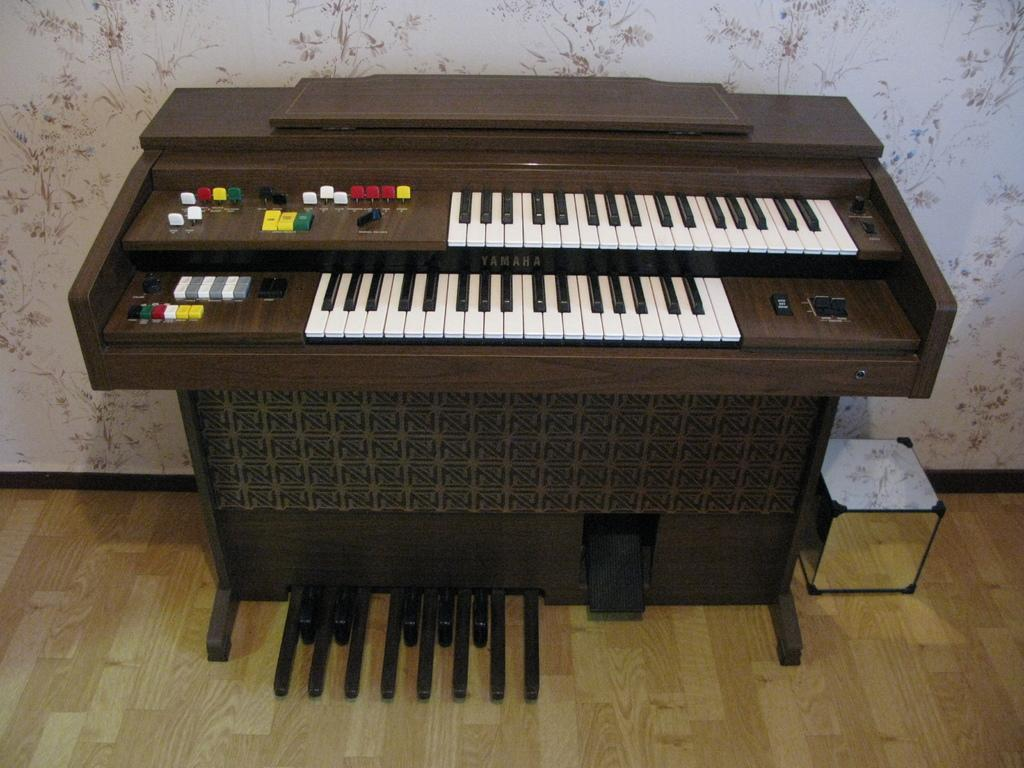What musical instrument is present in the image? There is a piano in the image. What object is located beside the piano? There is a box beside the piano. What can be seen in the background of the image? There is a wall in the background of the image. What type of flooring is visible in the image? There is a wooden floor visible in the image. What is the temperature of the room in the image? The temperature of the room is not mentioned in the image, so it cannot be determined. 